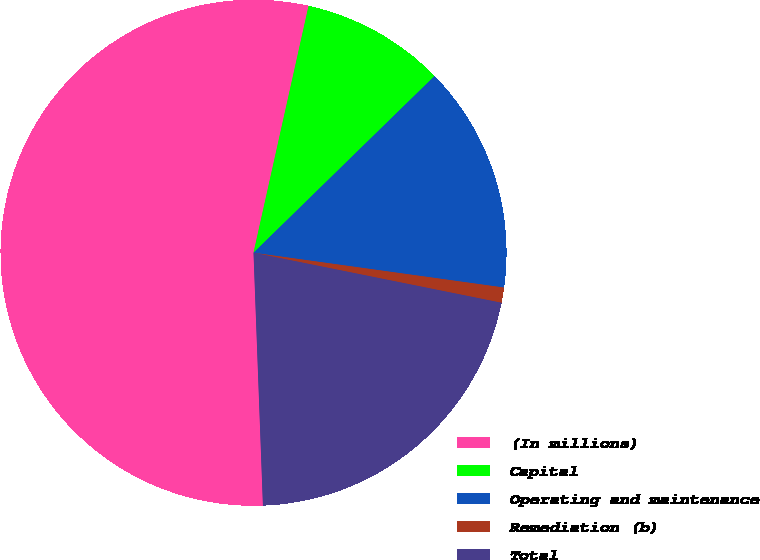Convert chart to OTSL. <chart><loc_0><loc_0><loc_500><loc_500><pie_chart><fcel>(In millions)<fcel>Capital<fcel>Operating and maintenance<fcel>Remediation (b)<fcel>Total<nl><fcel>54.09%<fcel>9.2%<fcel>14.51%<fcel>0.97%<fcel>21.24%<nl></chart> 